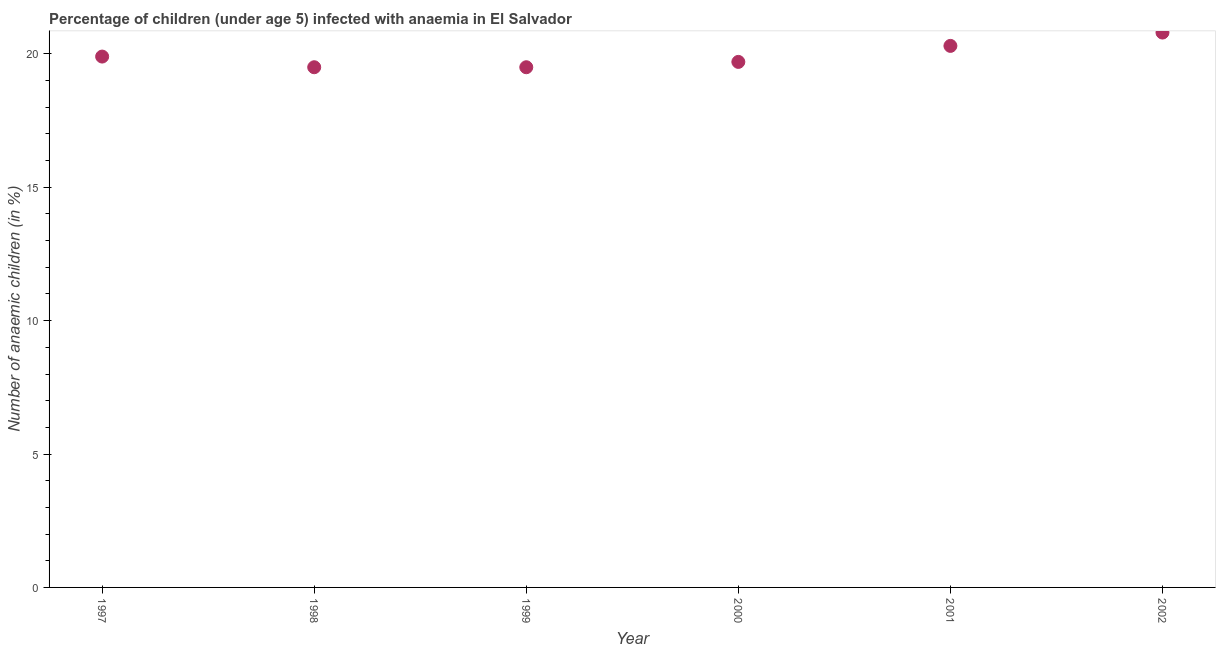What is the number of anaemic children in 2001?
Ensure brevity in your answer.  20.3. Across all years, what is the maximum number of anaemic children?
Offer a very short reply. 20.8. What is the sum of the number of anaemic children?
Your response must be concise. 119.7. What is the difference between the number of anaemic children in 1999 and 2001?
Provide a short and direct response. -0.8. What is the average number of anaemic children per year?
Provide a succinct answer. 19.95. What is the median number of anaemic children?
Keep it short and to the point. 19.8. In how many years, is the number of anaemic children greater than 2 %?
Offer a very short reply. 6. What is the ratio of the number of anaemic children in 1997 to that in 1999?
Give a very brief answer. 1.02. Is the difference between the number of anaemic children in 1997 and 1998 greater than the difference between any two years?
Your answer should be compact. No. Is the sum of the number of anaemic children in 1997 and 2000 greater than the maximum number of anaemic children across all years?
Keep it short and to the point. Yes. What is the difference between the highest and the lowest number of anaemic children?
Provide a succinct answer. 1.3. In how many years, is the number of anaemic children greater than the average number of anaemic children taken over all years?
Offer a very short reply. 2. Does the number of anaemic children monotonically increase over the years?
Make the answer very short. No. How many years are there in the graph?
Offer a terse response. 6. Are the values on the major ticks of Y-axis written in scientific E-notation?
Keep it short and to the point. No. Does the graph contain grids?
Your response must be concise. No. What is the title of the graph?
Provide a succinct answer. Percentage of children (under age 5) infected with anaemia in El Salvador. What is the label or title of the X-axis?
Provide a short and direct response. Year. What is the label or title of the Y-axis?
Offer a terse response. Number of anaemic children (in %). What is the Number of anaemic children (in %) in 1999?
Make the answer very short. 19.5. What is the Number of anaemic children (in %) in 2001?
Give a very brief answer. 20.3. What is the Number of anaemic children (in %) in 2002?
Offer a terse response. 20.8. What is the difference between the Number of anaemic children (in %) in 1997 and 2002?
Provide a succinct answer. -0.9. What is the difference between the Number of anaemic children (in %) in 1998 and 1999?
Your answer should be compact. 0. What is the difference between the Number of anaemic children (in %) in 1998 and 2001?
Ensure brevity in your answer.  -0.8. What is the difference between the Number of anaemic children (in %) in 1999 and 2000?
Make the answer very short. -0.2. What is the ratio of the Number of anaemic children (in %) in 1997 to that in 1999?
Provide a short and direct response. 1.02. What is the ratio of the Number of anaemic children (in %) in 1997 to that in 2001?
Keep it short and to the point. 0.98. What is the ratio of the Number of anaemic children (in %) in 1998 to that in 2002?
Offer a terse response. 0.94. What is the ratio of the Number of anaemic children (in %) in 1999 to that in 2000?
Provide a succinct answer. 0.99. What is the ratio of the Number of anaemic children (in %) in 1999 to that in 2001?
Provide a short and direct response. 0.96. What is the ratio of the Number of anaemic children (in %) in 1999 to that in 2002?
Your response must be concise. 0.94. What is the ratio of the Number of anaemic children (in %) in 2000 to that in 2002?
Offer a very short reply. 0.95. 